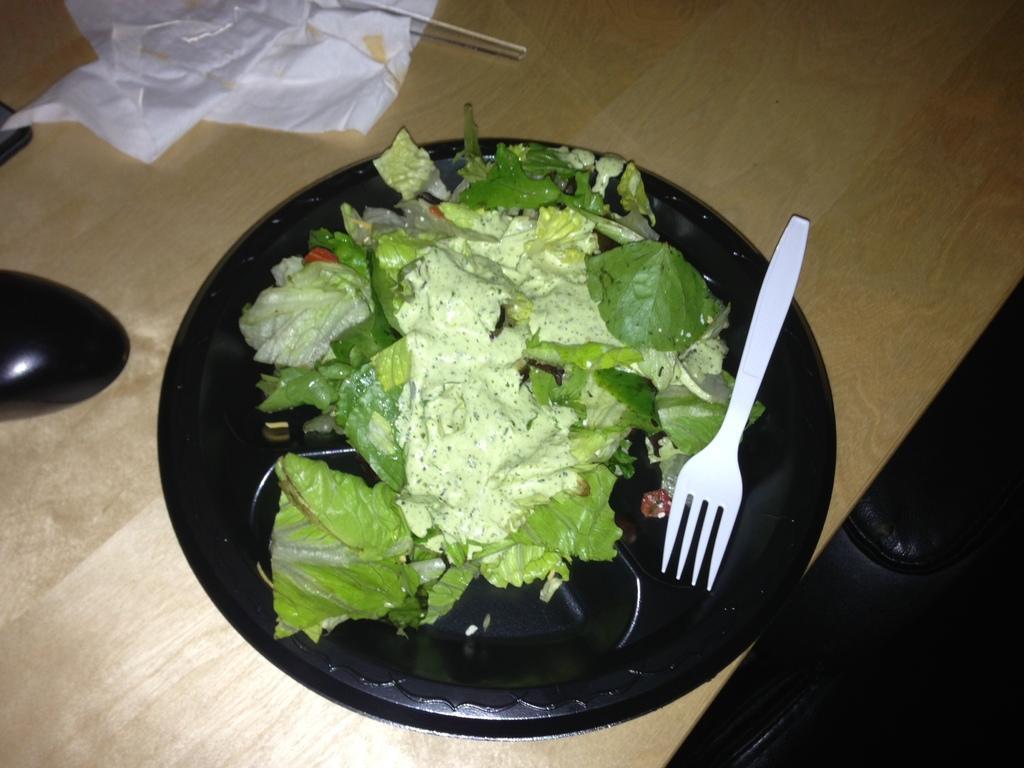How would you summarize this image in a sentence or two? In this image in the background there is one table, on the table there is one bowl. In that bowl there is salad and one fork and also there is a tissue paper and some other object on a table. 